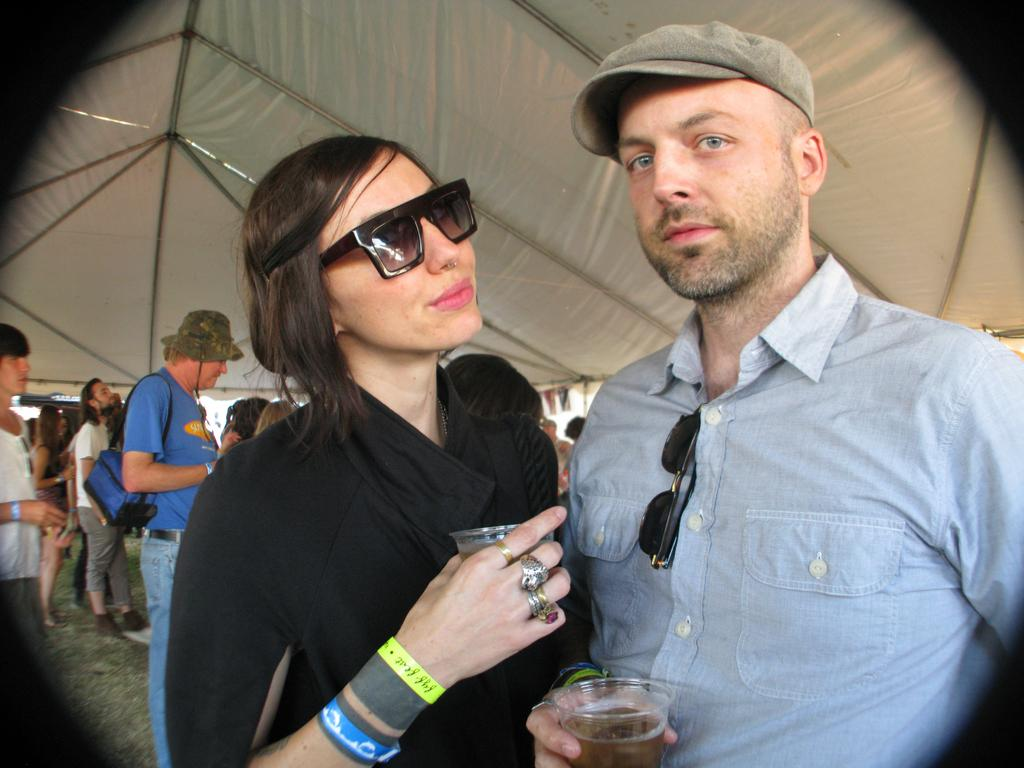What are the two people in the foreground of the image holding? The two people in the foreground of the image are holding glasses. What can be seen in the background of the image? There are people standing in the background of the image. What type of material is visible at the top of the image? There is a tent cloth visible at the top of the image. What type of friction is present between the glasses and the table in the image? There is no information about friction between the glasses and the table in the image, as the focus is on the people holding the glasses and the tent cloth at the top. 